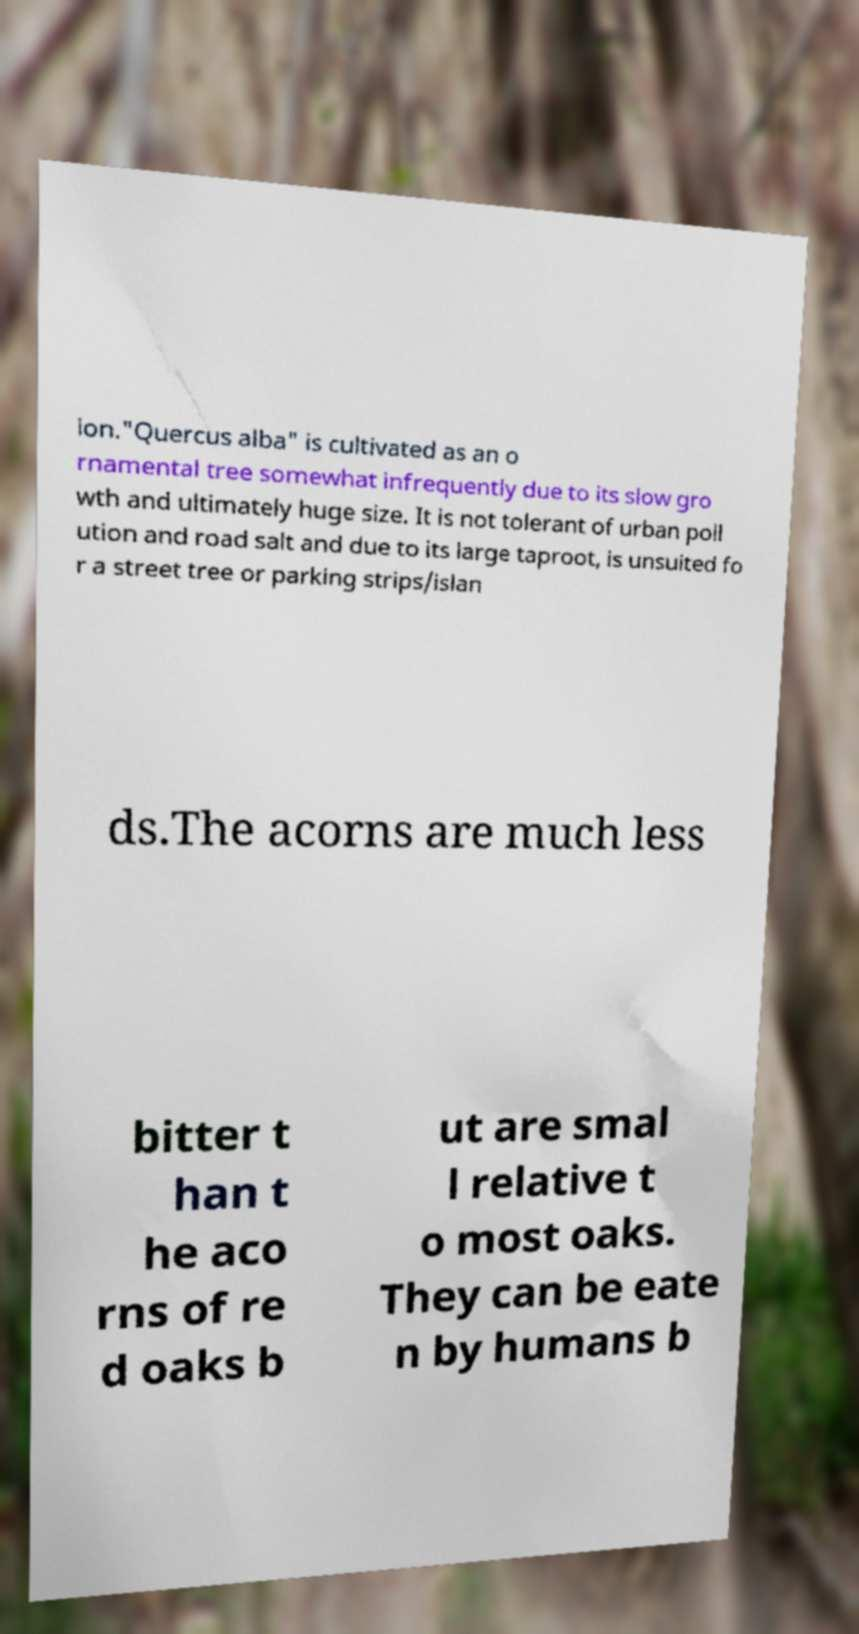I need the written content from this picture converted into text. Can you do that? ion."Quercus alba" is cultivated as an o rnamental tree somewhat infrequently due to its slow gro wth and ultimately huge size. It is not tolerant of urban poll ution and road salt and due to its large taproot, is unsuited fo r a street tree or parking strips/islan ds.The acorns are much less bitter t han t he aco rns of re d oaks b ut are smal l relative t o most oaks. They can be eate n by humans b 